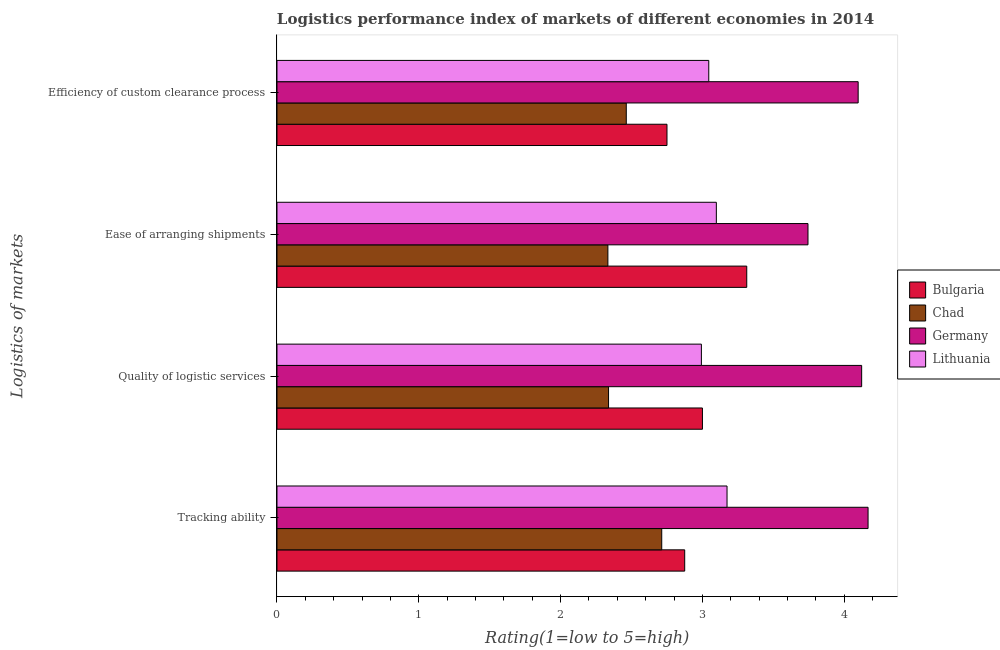How many different coloured bars are there?
Offer a terse response. 4. Are the number of bars per tick equal to the number of legend labels?
Your answer should be very brief. Yes. How many bars are there on the 3rd tick from the bottom?
Make the answer very short. 4. What is the label of the 2nd group of bars from the top?
Provide a short and direct response. Ease of arranging shipments. What is the lpi rating of efficiency of custom clearance process in Chad?
Provide a short and direct response. 2.46. Across all countries, what is the maximum lpi rating of ease of arranging shipments?
Make the answer very short. 3.74. Across all countries, what is the minimum lpi rating of quality of logistic services?
Ensure brevity in your answer.  2.34. In which country was the lpi rating of efficiency of custom clearance process maximum?
Your answer should be compact. Germany. In which country was the lpi rating of ease of arranging shipments minimum?
Keep it short and to the point. Chad. What is the total lpi rating of quality of logistic services in the graph?
Make the answer very short. 12.45. What is the difference between the lpi rating of quality of logistic services in Bulgaria and that in Lithuania?
Your answer should be very brief. 0.01. What is the difference between the lpi rating of efficiency of custom clearance process in Chad and the lpi rating of quality of logistic services in Bulgaria?
Give a very brief answer. -0.54. What is the average lpi rating of ease of arranging shipments per country?
Make the answer very short. 3.12. What is the ratio of the lpi rating of ease of arranging shipments in Bulgaria to that in Chad?
Your answer should be very brief. 1.42. Is the difference between the lpi rating of efficiency of custom clearance process in Chad and Germany greater than the difference between the lpi rating of ease of arranging shipments in Chad and Germany?
Provide a short and direct response. No. What is the difference between the highest and the second highest lpi rating of tracking ability?
Keep it short and to the point. 0.99. What is the difference between the highest and the lowest lpi rating of quality of logistic services?
Your answer should be compact. 1.78. What does the 2nd bar from the bottom in Quality of logistic services represents?
Offer a very short reply. Chad. Is it the case that in every country, the sum of the lpi rating of tracking ability and lpi rating of quality of logistic services is greater than the lpi rating of ease of arranging shipments?
Give a very brief answer. Yes. How many countries are there in the graph?
Make the answer very short. 4. Where does the legend appear in the graph?
Your response must be concise. Center right. How are the legend labels stacked?
Your response must be concise. Vertical. What is the title of the graph?
Your response must be concise. Logistics performance index of markets of different economies in 2014. What is the label or title of the X-axis?
Your response must be concise. Rating(1=low to 5=high). What is the label or title of the Y-axis?
Your response must be concise. Logistics of markets. What is the Rating(1=low to 5=high) of Bulgaria in Tracking ability?
Give a very brief answer. 2.88. What is the Rating(1=low to 5=high) in Chad in Tracking ability?
Provide a succinct answer. 2.71. What is the Rating(1=low to 5=high) in Germany in Tracking ability?
Offer a very short reply. 4.17. What is the Rating(1=low to 5=high) in Lithuania in Tracking ability?
Offer a terse response. 3.17. What is the Rating(1=low to 5=high) in Bulgaria in Quality of logistic services?
Provide a short and direct response. 3. What is the Rating(1=low to 5=high) in Chad in Quality of logistic services?
Make the answer very short. 2.34. What is the Rating(1=low to 5=high) of Germany in Quality of logistic services?
Ensure brevity in your answer.  4.12. What is the Rating(1=low to 5=high) of Lithuania in Quality of logistic services?
Provide a short and direct response. 2.99. What is the Rating(1=low to 5=high) of Bulgaria in Ease of arranging shipments?
Give a very brief answer. 3.31. What is the Rating(1=low to 5=high) of Chad in Ease of arranging shipments?
Offer a very short reply. 2.33. What is the Rating(1=low to 5=high) of Germany in Ease of arranging shipments?
Provide a succinct answer. 3.74. What is the Rating(1=low to 5=high) of Lithuania in Ease of arranging shipments?
Your answer should be compact. 3.1. What is the Rating(1=low to 5=high) in Bulgaria in Efficiency of custom clearance process?
Your response must be concise. 2.75. What is the Rating(1=low to 5=high) of Chad in Efficiency of custom clearance process?
Keep it short and to the point. 2.46. What is the Rating(1=low to 5=high) of Germany in Efficiency of custom clearance process?
Your response must be concise. 4.1. What is the Rating(1=low to 5=high) of Lithuania in Efficiency of custom clearance process?
Offer a very short reply. 3.04. Across all Logistics of markets, what is the maximum Rating(1=low to 5=high) of Bulgaria?
Make the answer very short. 3.31. Across all Logistics of markets, what is the maximum Rating(1=low to 5=high) in Chad?
Your answer should be compact. 2.71. Across all Logistics of markets, what is the maximum Rating(1=low to 5=high) of Germany?
Provide a succinct answer. 4.17. Across all Logistics of markets, what is the maximum Rating(1=low to 5=high) of Lithuania?
Provide a succinct answer. 3.17. Across all Logistics of markets, what is the minimum Rating(1=low to 5=high) of Bulgaria?
Ensure brevity in your answer.  2.75. Across all Logistics of markets, what is the minimum Rating(1=low to 5=high) of Chad?
Your answer should be compact. 2.33. Across all Logistics of markets, what is the minimum Rating(1=low to 5=high) of Germany?
Provide a succinct answer. 3.74. Across all Logistics of markets, what is the minimum Rating(1=low to 5=high) in Lithuania?
Provide a short and direct response. 2.99. What is the total Rating(1=low to 5=high) in Bulgaria in the graph?
Make the answer very short. 11.94. What is the total Rating(1=low to 5=high) in Chad in the graph?
Ensure brevity in your answer.  9.85. What is the total Rating(1=low to 5=high) in Germany in the graph?
Make the answer very short. 16.13. What is the total Rating(1=low to 5=high) of Lithuania in the graph?
Offer a very short reply. 12.31. What is the difference between the Rating(1=low to 5=high) of Bulgaria in Tracking ability and that in Quality of logistic services?
Your answer should be very brief. -0.12. What is the difference between the Rating(1=low to 5=high) of Chad in Tracking ability and that in Quality of logistic services?
Ensure brevity in your answer.  0.38. What is the difference between the Rating(1=low to 5=high) in Germany in Tracking ability and that in Quality of logistic services?
Offer a terse response. 0.05. What is the difference between the Rating(1=low to 5=high) in Lithuania in Tracking ability and that in Quality of logistic services?
Your answer should be very brief. 0.18. What is the difference between the Rating(1=low to 5=high) in Bulgaria in Tracking ability and that in Ease of arranging shipments?
Your response must be concise. -0.44. What is the difference between the Rating(1=low to 5=high) in Chad in Tracking ability and that in Ease of arranging shipments?
Ensure brevity in your answer.  0.38. What is the difference between the Rating(1=low to 5=high) of Germany in Tracking ability and that in Ease of arranging shipments?
Ensure brevity in your answer.  0.42. What is the difference between the Rating(1=low to 5=high) in Lithuania in Tracking ability and that in Ease of arranging shipments?
Provide a succinct answer. 0.08. What is the difference between the Rating(1=low to 5=high) of Bulgaria in Tracking ability and that in Efficiency of custom clearance process?
Offer a terse response. 0.12. What is the difference between the Rating(1=low to 5=high) in Germany in Tracking ability and that in Efficiency of custom clearance process?
Ensure brevity in your answer.  0.07. What is the difference between the Rating(1=low to 5=high) of Lithuania in Tracking ability and that in Efficiency of custom clearance process?
Your answer should be compact. 0.13. What is the difference between the Rating(1=low to 5=high) of Bulgaria in Quality of logistic services and that in Ease of arranging shipments?
Give a very brief answer. -0.31. What is the difference between the Rating(1=low to 5=high) of Chad in Quality of logistic services and that in Ease of arranging shipments?
Give a very brief answer. 0. What is the difference between the Rating(1=low to 5=high) of Germany in Quality of logistic services and that in Ease of arranging shipments?
Provide a short and direct response. 0.38. What is the difference between the Rating(1=low to 5=high) in Lithuania in Quality of logistic services and that in Ease of arranging shipments?
Offer a very short reply. -0.11. What is the difference between the Rating(1=low to 5=high) in Bulgaria in Quality of logistic services and that in Efficiency of custom clearance process?
Give a very brief answer. 0.25. What is the difference between the Rating(1=low to 5=high) of Chad in Quality of logistic services and that in Efficiency of custom clearance process?
Keep it short and to the point. -0.12. What is the difference between the Rating(1=low to 5=high) of Germany in Quality of logistic services and that in Efficiency of custom clearance process?
Give a very brief answer. 0.02. What is the difference between the Rating(1=low to 5=high) of Lithuania in Quality of logistic services and that in Efficiency of custom clearance process?
Ensure brevity in your answer.  -0.05. What is the difference between the Rating(1=low to 5=high) in Bulgaria in Ease of arranging shipments and that in Efficiency of custom clearance process?
Your answer should be very brief. 0.56. What is the difference between the Rating(1=low to 5=high) of Chad in Ease of arranging shipments and that in Efficiency of custom clearance process?
Keep it short and to the point. -0.13. What is the difference between the Rating(1=low to 5=high) of Germany in Ease of arranging shipments and that in Efficiency of custom clearance process?
Give a very brief answer. -0.35. What is the difference between the Rating(1=low to 5=high) of Lithuania in Ease of arranging shipments and that in Efficiency of custom clearance process?
Your response must be concise. 0.05. What is the difference between the Rating(1=low to 5=high) in Bulgaria in Tracking ability and the Rating(1=low to 5=high) in Chad in Quality of logistic services?
Provide a short and direct response. 0.54. What is the difference between the Rating(1=low to 5=high) in Bulgaria in Tracking ability and the Rating(1=low to 5=high) in Germany in Quality of logistic services?
Your answer should be very brief. -1.25. What is the difference between the Rating(1=low to 5=high) of Bulgaria in Tracking ability and the Rating(1=low to 5=high) of Lithuania in Quality of logistic services?
Provide a short and direct response. -0.12. What is the difference between the Rating(1=low to 5=high) of Chad in Tracking ability and the Rating(1=low to 5=high) of Germany in Quality of logistic services?
Your answer should be compact. -1.41. What is the difference between the Rating(1=low to 5=high) in Chad in Tracking ability and the Rating(1=low to 5=high) in Lithuania in Quality of logistic services?
Ensure brevity in your answer.  -0.28. What is the difference between the Rating(1=low to 5=high) in Germany in Tracking ability and the Rating(1=low to 5=high) in Lithuania in Quality of logistic services?
Keep it short and to the point. 1.18. What is the difference between the Rating(1=low to 5=high) in Bulgaria in Tracking ability and the Rating(1=low to 5=high) in Chad in Ease of arranging shipments?
Make the answer very short. 0.54. What is the difference between the Rating(1=low to 5=high) in Bulgaria in Tracking ability and the Rating(1=low to 5=high) in Germany in Ease of arranging shipments?
Your response must be concise. -0.87. What is the difference between the Rating(1=low to 5=high) in Bulgaria in Tracking ability and the Rating(1=low to 5=high) in Lithuania in Ease of arranging shipments?
Your response must be concise. -0.22. What is the difference between the Rating(1=low to 5=high) of Chad in Tracking ability and the Rating(1=low to 5=high) of Germany in Ease of arranging shipments?
Offer a very short reply. -1.03. What is the difference between the Rating(1=low to 5=high) of Chad in Tracking ability and the Rating(1=low to 5=high) of Lithuania in Ease of arranging shipments?
Ensure brevity in your answer.  -0.39. What is the difference between the Rating(1=low to 5=high) in Germany in Tracking ability and the Rating(1=low to 5=high) in Lithuania in Ease of arranging shipments?
Provide a short and direct response. 1.07. What is the difference between the Rating(1=low to 5=high) of Bulgaria in Tracking ability and the Rating(1=low to 5=high) of Chad in Efficiency of custom clearance process?
Offer a very short reply. 0.41. What is the difference between the Rating(1=low to 5=high) in Bulgaria in Tracking ability and the Rating(1=low to 5=high) in Germany in Efficiency of custom clearance process?
Your response must be concise. -1.22. What is the difference between the Rating(1=low to 5=high) in Bulgaria in Tracking ability and the Rating(1=low to 5=high) in Lithuania in Efficiency of custom clearance process?
Give a very brief answer. -0.17. What is the difference between the Rating(1=low to 5=high) in Chad in Tracking ability and the Rating(1=low to 5=high) in Germany in Efficiency of custom clearance process?
Offer a terse response. -1.39. What is the difference between the Rating(1=low to 5=high) in Chad in Tracking ability and the Rating(1=low to 5=high) in Lithuania in Efficiency of custom clearance process?
Your response must be concise. -0.33. What is the difference between the Rating(1=low to 5=high) of Germany in Tracking ability and the Rating(1=low to 5=high) of Lithuania in Efficiency of custom clearance process?
Provide a succinct answer. 1.12. What is the difference between the Rating(1=low to 5=high) of Bulgaria in Quality of logistic services and the Rating(1=low to 5=high) of Chad in Ease of arranging shipments?
Offer a very short reply. 0.67. What is the difference between the Rating(1=low to 5=high) in Bulgaria in Quality of logistic services and the Rating(1=low to 5=high) in Germany in Ease of arranging shipments?
Offer a terse response. -0.74. What is the difference between the Rating(1=low to 5=high) of Bulgaria in Quality of logistic services and the Rating(1=low to 5=high) of Lithuania in Ease of arranging shipments?
Your response must be concise. -0.1. What is the difference between the Rating(1=low to 5=high) in Chad in Quality of logistic services and the Rating(1=low to 5=high) in Germany in Ease of arranging shipments?
Give a very brief answer. -1.41. What is the difference between the Rating(1=low to 5=high) in Chad in Quality of logistic services and the Rating(1=low to 5=high) in Lithuania in Ease of arranging shipments?
Give a very brief answer. -0.76. What is the difference between the Rating(1=low to 5=high) in Germany in Quality of logistic services and the Rating(1=low to 5=high) in Lithuania in Ease of arranging shipments?
Keep it short and to the point. 1.02. What is the difference between the Rating(1=low to 5=high) in Bulgaria in Quality of logistic services and the Rating(1=low to 5=high) in Chad in Efficiency of custom clearance process?
Offer a terse response. 0.54. What is the difference between the Rating(1=low to 5=high) of Bulgaria in Quality of logistic services and the Rating(1=low to 5=high) of Germany in Efficiency of custom clearance process?
Make the answer very short. -1.1. What is the difference between the Rating(1=low to 5=high) of Bulgaria in Quality of logistic services and the Rating(1=low to 5=high) of Lithuania in Efficiency of custom clearance process?
Give a very brief answer. -0.04. What is the difference between the Rating(1=low to 5=high) of Chad in Quality of logistic services and the Rating(1=low to 5=high) of Germany in Efficiency of custom clearance process?
Ensure brevity in your answer.  -1.76. What is the difference between the Rating(1=low to 5=high) of Chad in Quality of logistic services and the Rating(1=low to 5=high) of Lithuania in Efficiency of custom clearance process?
Offer a terse response. -0.71. What is the difference between the Rating(1=low to 5=high) of Germany in Quality of logistic services and the Rating(1=low to 5=high) of Lithuania in Efficiency of custom clearance process?
Provide a succinct answer. 1.08. What is the difference between the Rating(1=low to 5=high) of Bulgaria in Ease of arranging shipments and the Rating(1=low to 5=high) of Chad in Efficiency of custom clearance process?
Your response must be concise. 0.85. What is the difference between the Rating(1=low to 5=high) of Bulgaria in Ease of arranging shipments and the Rating(1=low to 5=high) of Germany in Efficiency of custom clearance process?
Your response must be concise. -0.79. What is the difference between the Rating(1=low to 5=high) of Bulgaria in Ease of arranging shipments and the Rating(1=low to 5=high) of Lithuania in Efficiency of custom clearance process?
Offer a very short reply. 0.27. What is the difference between the Rating(1=low to 5=high) in Chad in Ease of arranging shipments and the Rating(1=low to 5=high) in Germany in Efficiency of custom clearance process?
Your answer should be very brief. -1.76. What is the difference between the Rating(1=low to 5=high) of Chad in Ease of arranging shipments and the Rating(1=low to 5=high) of Lithuania in Efficiency of custom clearance process?
Offer a terse response. -0.71. What is the difference between the Rating(1=low to 5=high) in Germany in Ease of arranging shipments and the Rating(1=low to 5=high) in Lithuania in Efficiency of custom clearance process?
Your response must be concise. 0.7. What is the average Rating(1=low to 5=high) of Bulgaria per Logistics of markets?
Make the answer very short. 2.98. What is the average Rating(1=low to 5=high) of Chad per Logistics of markets?
Make the answer very short. 2.46. What is the average Rating(1=low to 5=high) in Germany per Logistics of markets?
Make the answer very short. 4.03. What is the average Rating(1=low to 5=high) of Lithuania per Logistics of markets?
Offer a very short reply. 3.08. What is the difference between the Rating(1=low to 5=high) of Bulgaria and Rating(1=low to 5=high) of Chad in Tracking ability?
Your answer should be compact. 0.16. What is the difference between the Rating(1=low to 5=high) of Bulgaria and Rating(1=low to 5=high) of Germany in Tracking ability?
Your response must be concise. -1.29. What is the difference between the Rating(1=low to 5=high) in Bulgaria and Rating(1=low to 5=high) in Lithuania in Tracking ability?
Offer a very short reply. -0.3. What is the difference between the Rating(1=low to 5=high) of Chad and Rating(1=low to 5=high) of Germany in Tracking ability?
Provide a short and direct response. -1.46. What is the difference between the Rating(1=low to 5=high) of Chad and Rating(1=low to 5=high) of Lithuania in Tracking ability?
Keep it short and to the point. -0.46. What is the difference between the Rating(1=low to 5=high) in Bulgaria and Rating(1=low to 5=high) in Chad in Quality of logistic services?
Your answer should be very brief. 0.66. What is the difference between the Rating(1=low to 5=high) of Bulgaria and Rating(1=low to 5=high) of Germany in Quality of logistic services?
Offer a very short reply. -1.12. What is the difference between the Rating(1=low to 5=high) in Bulgaria and Rating(1=low to 5=high) in Lithuania in Quality of logistic services?
Make the answer very short. 0.01. What is the difference between the Rating(1=low to 5=high) in Chad and Rating(1=low to 5=high) in Germany in Quality of logistic services?
Offer a very short reply. -1.78. What is the difference between the Rating(1=low to 5=high) of Chad and Rating(1=low to 5=high) of Lithuania in Quality of logistic services?
Your answer should be very brief. -0.65. What is the difference between the Rating(1=low to 5=high) in Germany and Rating(1=low to 5=high) in Lithuania in Quality of logistic services?
Your answer should be compact. 1.13. What is the difference between the Rating(1=low to 5=high) in Bulgaria and Rating(1=low to 5=high) in Chad in Ease of arranging shipments?
Give a very brief answer. 0.98. What is the difference between the Rating(1=low to 5=high) in Bulgaria and Rating(1=low to 5=high) in Germany in Ease of arranging shipments?
Offer a very short reply. -0.43. What is the difference between the Rating(1=low to 5=high) in Bulgaria and Rating(1=low to 5=high) in Lithuania in Ease of arranging shipments?
Your response must be concise. 0.21. What is the difference between the Rating(1=low to 5=high) of Chad and Rating(1=low to 5=high) of Germany in Ease of arranging shipments?
Ensure brevity in your answer.  -1.41. What is the difference between the Rating(1=low to 5=high) of Chad and Rating(1=low to 5=high) of Lithuania in Ease of arranging shipments?
Make the answer very short. -0.76. What is the difference between the Rating(1=low to 5=high) in Germany and Rating(1=low to 5=high) in Lithuania in Ease of arranging shipments?
Your response must be concise. 0.65. What is the difference between the Rating(1=low to 5=high) of Bulgaria and Rating(1=low to 5=high) of Chad in Efficiency of custom clearance process?
Your response must be concise. 0.29. What is the difference between the Rating(1=low to 5=high) in Bulgaria and Rating(1=low to 5=high) in Germany in Efficiency of custom clearance process?
Your answer should be compact. -1.35. What is the difference between the Rating(1=low to 5=high) of Bulgaria and Rating(1=low to 5=high) of Lithuania in Efficiency of custom clearance process?
Your answer should be very brief. -0.29. What is the difference between the Rating(1=low to 5=high) of Chad and Rating(1=low to 5=high) of Germany in Efficiency of custom clearance process?
Provide a succinct answer. -1.64. What is the difference between the Rating(1=low to 5=high) of Chad and Rating(1=low to 5=high) of Lithuania in Efficiency of custom clearance process?
Your answer should be very brief. -0.58. What is the difference between the Rating(1=low to 5=high) in Germany and Rating(1=low to 5=high) in Lithuania in Efficiency of custom clearance process?
Give a very brief answer. 1.05. What is the ratio of the Rating(1=low to 5=high) of Bulgaria in Tracking ability to that in Quality of logistic services?
Keep it short and to the point. 0.96. What is the ratio of the Rating(1=low to 5=high) in Chad in Tracking ability to that in Quality of logistic services?
Give a very brief answer. 1.16. What is the ratio of the Rating(1=low to 5=high) of Lithuania in Tracking ability to that in Quality of logistic services?
Provide a short and direct response. 1.06. What is the ratio of the Rating(1=low to 5=high) of Bulgaria in Tracking ability to that in Ease of arranging shipments?
Provide a succinct answer. 0.87. What is the ratio of the Rating(1=low to 5=high) of Chad in Tracking ability to that in Ease of arranging shipments?
Provide a succinct answer. 1.16. What is the ratio of the Rating(1=low to 5=high) in Germany in Tracking ability to that in Ease of arranging shipments?
Your answer should be compact. 1.11. What is the ratio of the Rating(1=low to 5=high) in Lithuania in Tracking ability to that in Ease of arranging shipments?
Provide a succinct answer. 1.02. What is the ratio of the Rating(1=low to 5=high) of Bulgaria in Tracking ability to that in Efficiency of custom clearance process?
Ensure brevity in your answer.  1.05. What is the ratio of the Rating(1=low to 5=high) of Chad in Tracking ability to that in Efficiency of custom clearance process?
Offer a terse response. 1.1. What is the ratio of the Rating(1=low to 5=high) of Lithuania in Tracking ability to that in Efficiency of custom clearance process?
Keep it short and to the point. 1.04. What is the ratio of the Rating(1=low to 5=high) in Bulgaria in Quality of logistic services to that in Ease of arranging shipments?
Keep it short and to the point. 0.91. What is the ratio of the Rating(1=low to 5=high) of Germany in Quality of logistic services to that in Ease of arranging shipments?
Provide a succinct answer. 1.1. What is the ratio of the Rating(1=low to 5=high) in Lithuania in Quality of logistic services to that in Ease of arranging shipments?
Your answer should be compact. 0.97. What is the ratio of the Rating(1=low to 5=high) in Chad in Quality of logistic services to that in Efficiency of custom clearance process?
Your answer should be very brief. 0.95. What is the ratio of the Rating(1=low to 5=high) of Lithuania in Quality of logistic services to that in Efficiency of custom clearance process?
Make the answer very short. 0.98. What is the ratio of the Rating(1=low to 5=high) of Bulgaria in Ease of arranging shipments to that in Efficiency of custom clearance process?
Your answer should be compact. 1.2. What is the ratio of the Rating(1=low to 5=high) in Germany in Ease of arranging shipments to that in Efficiency of custom clearance process?
Give a very brief answer. 0.91. What is the ratio of the Rating(1=low to 5=high) of Lithuania in Ease of arranging shipments to that in Efficiency of custom clearance process?
Give a very brief answer. 1.02. What is the difference between the highest and the second highest Rating(1=low to 5=high) of Bulgaria?
Keep it short and to the point. 0.31. What is the difference between the highest and the second highest Rating(1=low to 5=high) of Chad?
Make the answer very short. 0.25. What is the difference between the highest and the second highest Rating(1=low to 5=high) of Germany?
Make the answer very short. 0.05. What is the difference between the highest and the second highest Rating(1=low to 5=high) in Lithuania?
Offer a terse response. 0.08. What is the difference between the highest and the lowest Rating(1=low to 5=high) of Bulgaria?
Your response must be concise. 0.56. What is the difference between the highest and the lowest Rating(1=low to 5=high) of Chad?
Offer a terse response. 0.38. What is the difference between the highest and the lowest Rating(1=low to 5=high) of Germany?
Provide a short and direct response. 0.42. What is the difference between the highest and the lowest Rating(1=low to 5=high) in Lithuania?
Offer a terse response. 0.18. 